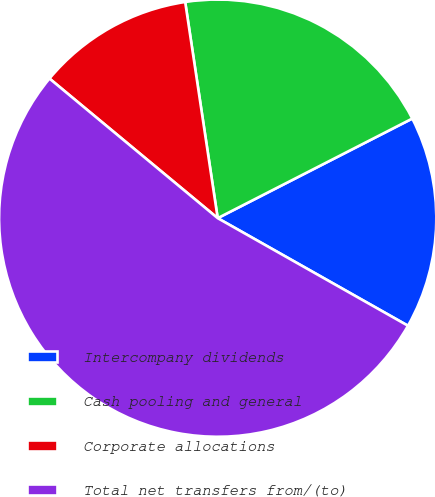Convert chart. <chart><loc_0><loc_0><loc_500><loc_500><pie_chart><fcel>Intercompany dividends<fcel>Cash pooling and general<fcel>Corporate allocations<fcel>Total net transfers from/(to)<nl><fcel>15.72%<fcel>19.85%<fcel>11.6%<fcel>52.84%<nl></chart> 